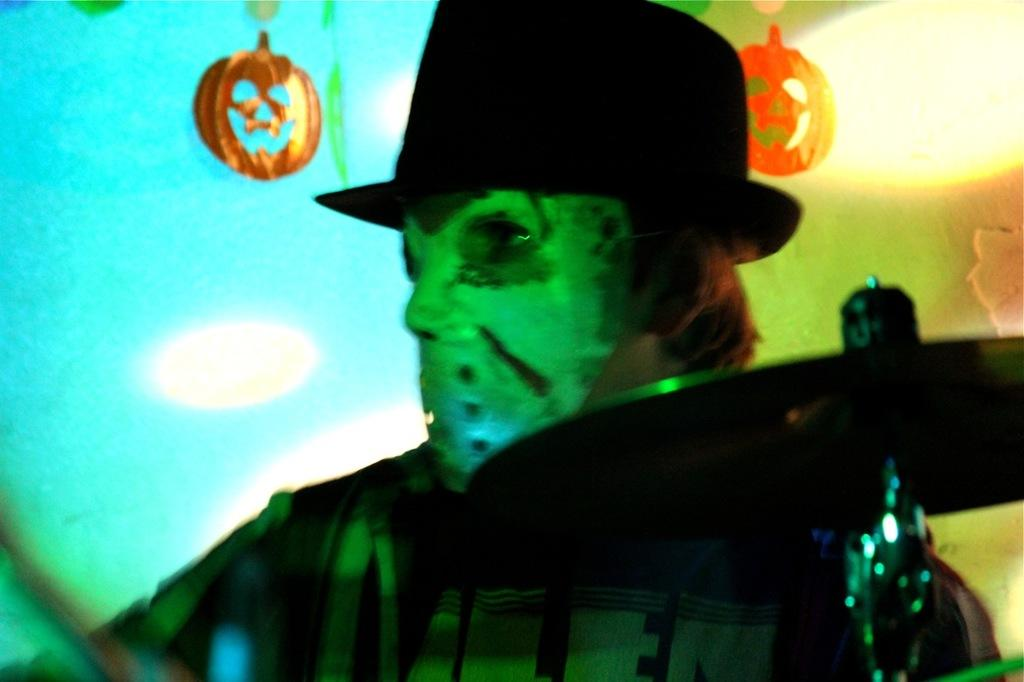Who is in the image? There is a person in the image. What is the person wearing on their face? The person is wearing a mask. What can be seen behind the person? There is a wall in the background of the image. What type of decorations are present in the background? Halloween decorations are present in the background of the image. What type of coil is the boy playing with in the alley? There is no boy or coil present in the image. The image features a person wearing a mask with Halloween decorations in the background. 